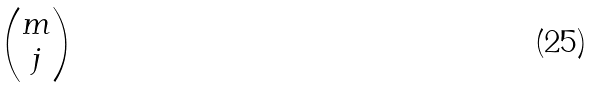<formula> <loc_0><loc_0><loc_500><loc_500>\begin{pmatrix} m \\ j \end{pmatrix}</formula> 